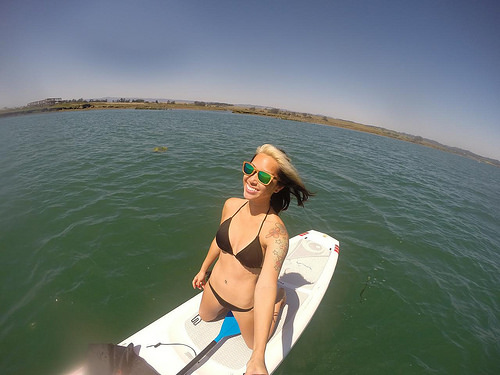<image>
Is the girl on the water? Yes. Looking at the image, I can see the girl is positioned on top of the water, with the water providing support. Where is the water in relation to the boat? Is it behind the boat? Yes. From this viewpoint, the water is positioned behind the boat, with the boat partially or fully occluding the water. Is there a person in front of the sea? No. The person is not in front of the sea. The spatial positioning shows a different relationship between these objects. 